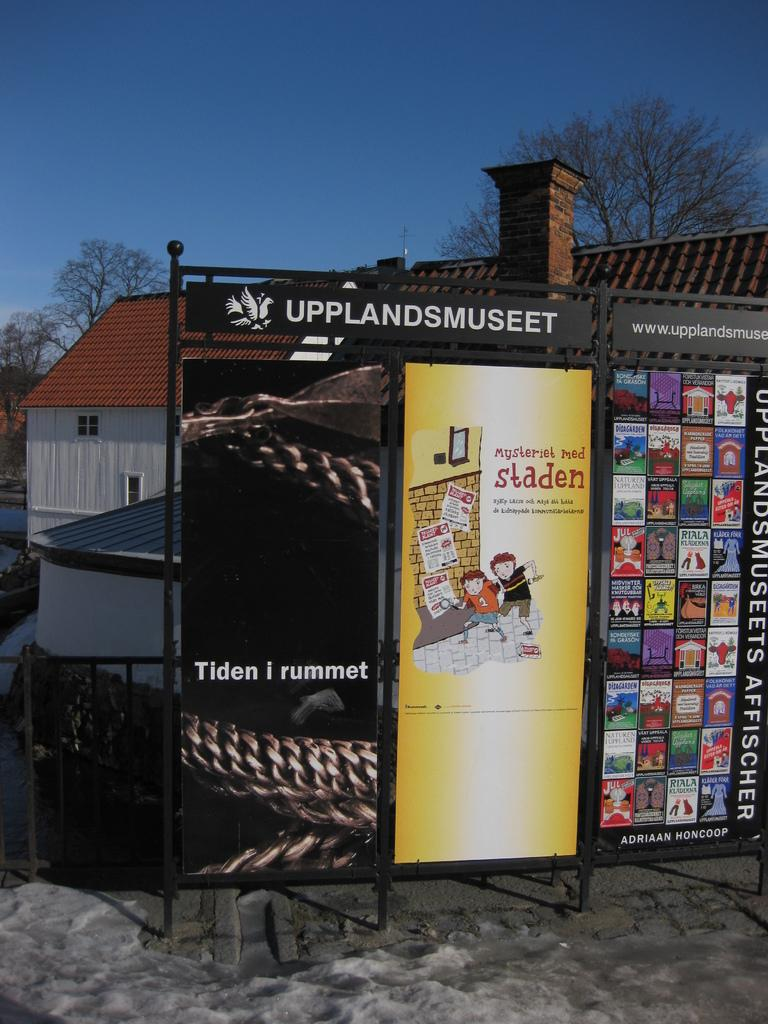<image>
Relay a brief, clear account of the picture shown. A series of posters on an outside stand in a foreign language. 